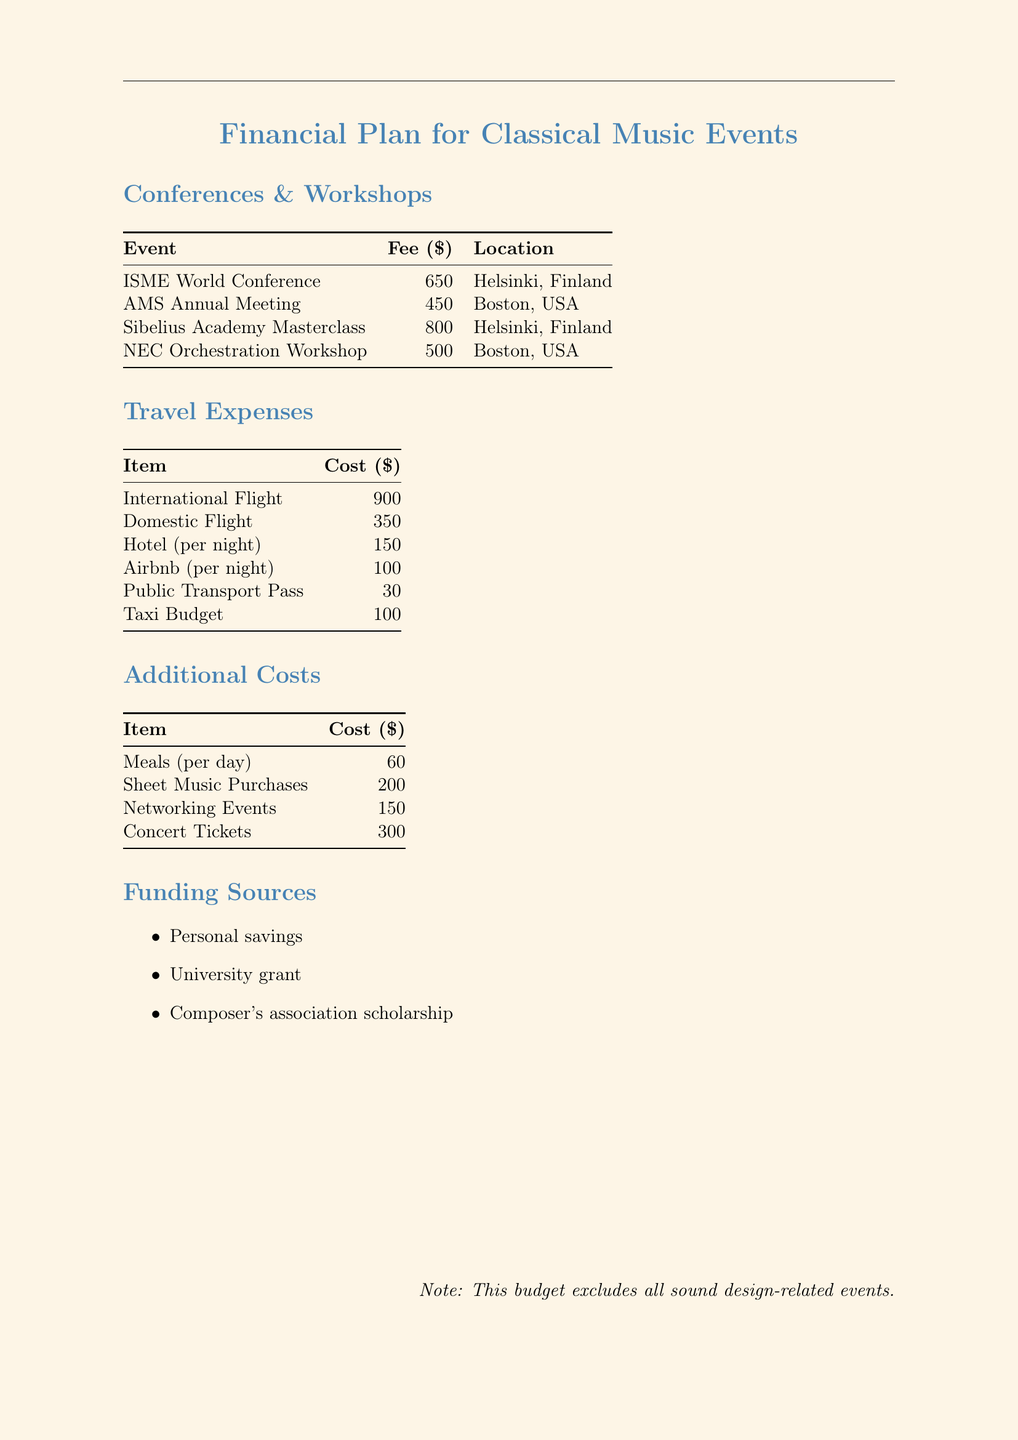What is the fee for the ISME World Conference? This fee is listed in the Conferences & Workshops table.
Answer: 650 Where is the AMS Annual Meeting held? The location for this meeting is provided in the Conferences & Workshops table.
Answer: Boston, USA What is the cost of hotel accommodation per night? This cost appears in the Travel Expenses section.
Answer: 150 How much are meals estimated to cost per day? The daily cost for meals can be found in the Additional Costs section.
Answer: 60 What is the total cost of attending the Sibelius Academy Masterclass? To find this, add the fee for the masterclass and relevant travel and additional costs, as detailed in the document.
Answer: 1950 Which funding source is listed as a scholarship? This information is found in the Funding Sources section.
Answer: Composer's association scholarship What type of events are excluded from the budget? The document explicitly states these exclusions.
Answer: Sound design-related events How much is the budget for concert tickets? The concert ticket cost is specified in the Additional Costs section.
Answer: 300 What is the cost for a public transport pass? This cost is detailed in the Travel Expenses table.
Answer: 30 